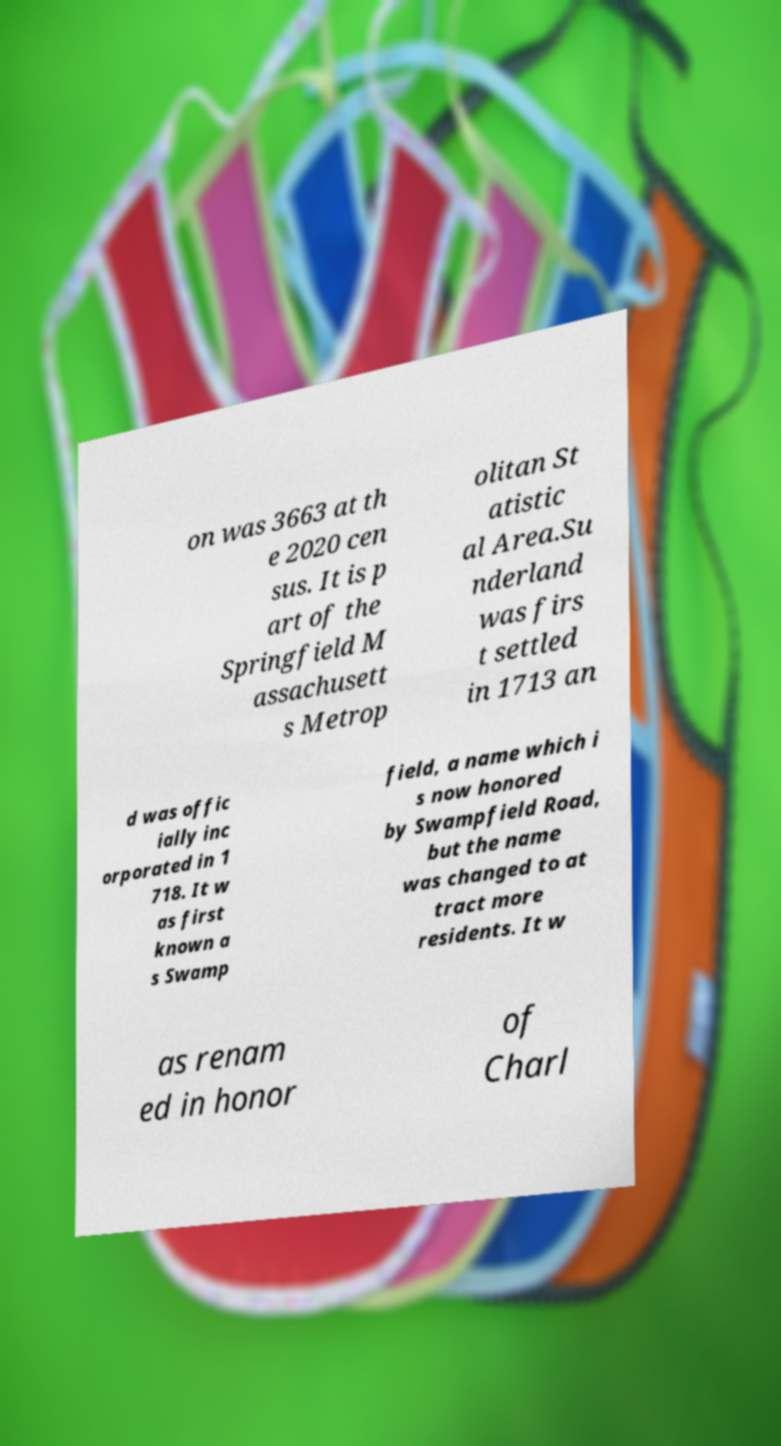I need the written content from this picture converted into text. Can you do that? on was 3663 at th e 2020 cen sus. It is p art of the Springfield M assachusett s Metrop olitan St atistic al Area.Su nderland was firs t settled in 1713 an d was offic ially inc orporated in 1 718. It w as first known a s Swamp field, a name which i s now honored by Swampfield Road, but the name was changed to at tract more residents. It w as renam ed in honor of Charl 